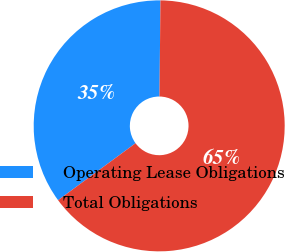Convert chart to OTSL. <chart><loc_0><loc_0><loc_500><loc_500><pie_chart><fcel>Operating Lease Obligations<fcel>Total Obligations<nl><fcel>35.25%<fcel>64.75%<nl></chart> 